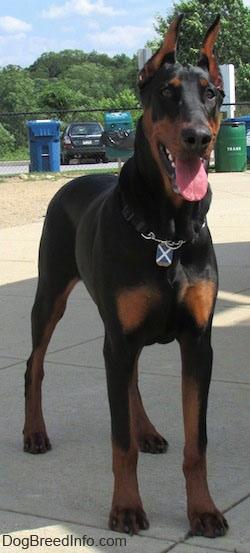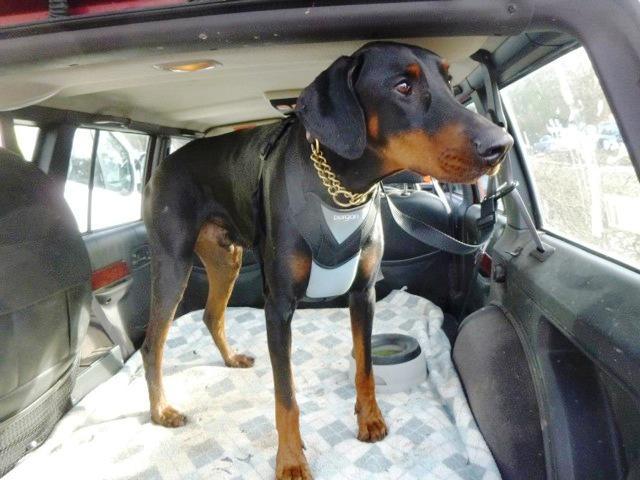The first image is the image on the left, the second image is the image on the right. For the images displayed, is the sentence "There are 3 dogs in cars." factually correct? Answer yes or no. No. The first image is the image on the left, the second image is the image on the right. Assess this claim about the two images: "There are exactly three dogs in total.". Correct or not? Answer yes or no. No. 